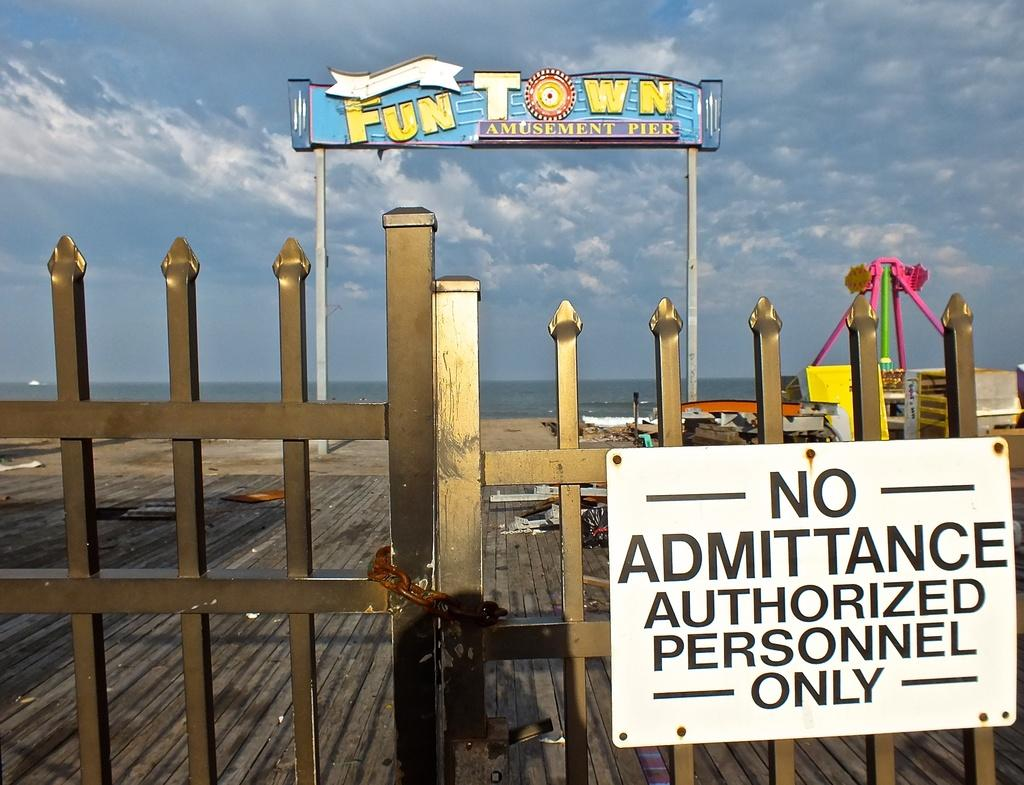Provide a one-sentence caption for the provided image. A closed gate says there is no admittance to the amusement pier. 